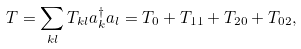<formula> <loc_0><loc_0><loc_500><loc_500>T = \sum _ { k l } T _ { k l } a ^ { \dag } _ { k } a _ { l } = T _ { 0 } + T _ { 1 1 } + T _ { 2 0 } + T _ { 0 2 } ,</formula> 